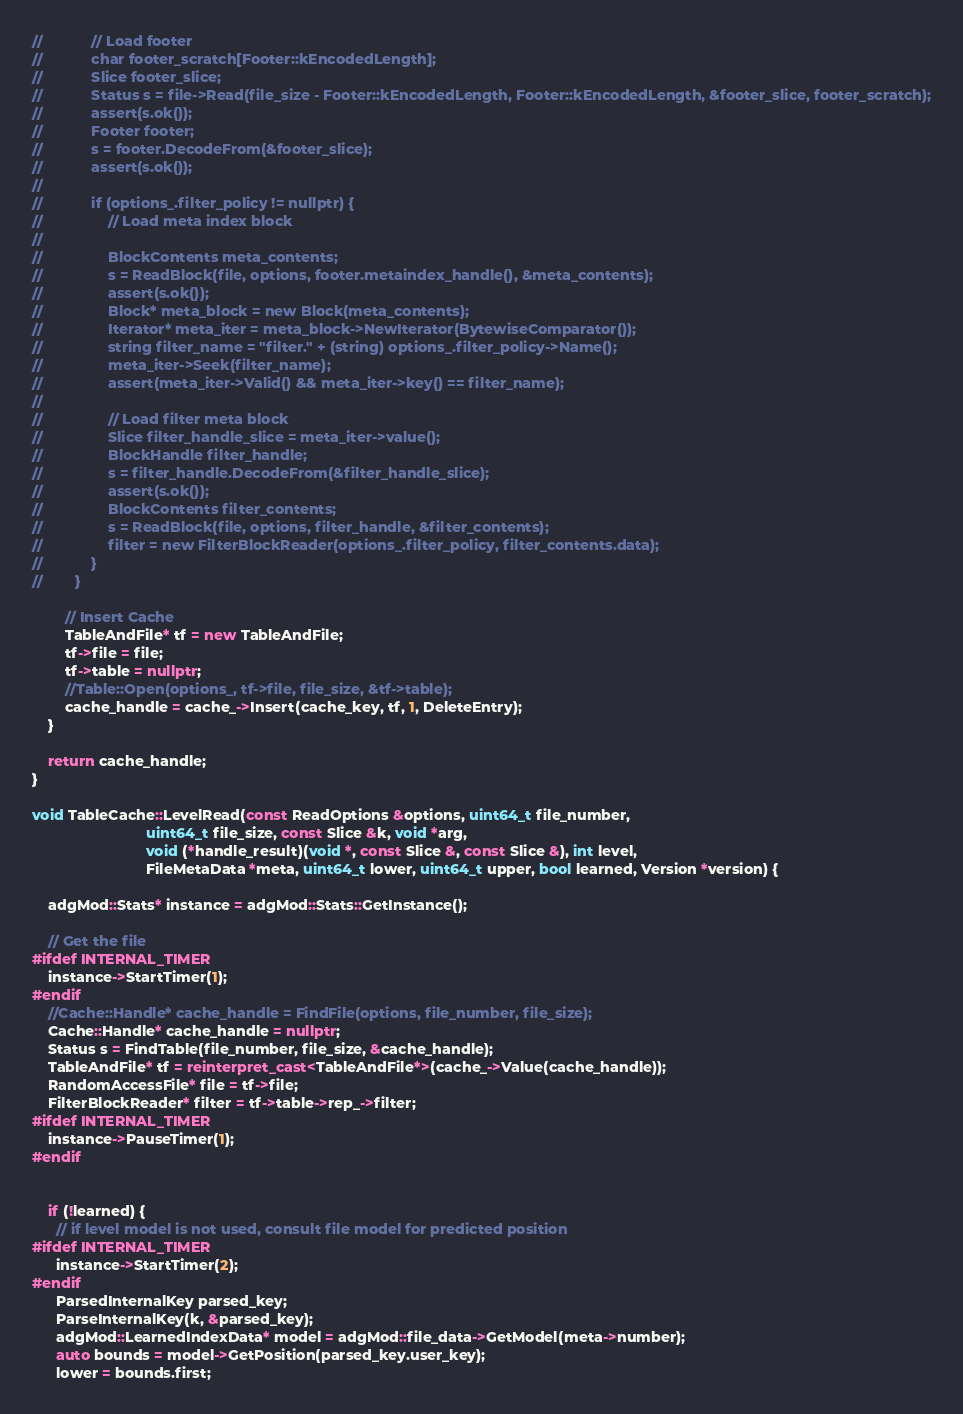<code> <loc_0><loc_0><loc_500><loc_500><_C++_>//            // Load footer
//            char footer_scratch[Footer::kEncodedLength];
//            Slice footer_slice;
//            Status s = file->Read(file_size - Footer::kEncodedLength, Footer::kEncodedLength, &footer_slice, footer_scratch);
//            assert(s.ok());
//            Footer footer;
//            s = footer.DecodeFrom(&footer_slice);
//            assert(s.ok());
//
//            if (options_.filter_policy != nullptr) {
//                // Load meta index block
//
//                BlockContents meta_contents;
//                s = ReadBlock(file, options, footer.metaindex_handle(), &meta_contents);
//                assert(s.ok());
//                Block* meta_block = new Block(meta_contents);
//                Iterator* meta_iter = meta_block->NewIterator(BytewiseComparator());
//                string filter_name = "filter." + (string) options_.filter_policy->Name();
//                meta_iter->Seek(filter_name);
//                assert(meta_iter->Valid() && meta_iter->key() == filter_name);
//
//                // Load filter meta block
//                Slice filter_handle_slice = meta_iter->value();
//                BlockHandle filter_handle;
//                s = filter_handle.DecodeFrom(&filter_handle_slice);
//                assert(s.ok());
//                BlockContents filter_contents;
//                s = ReadBlock(file, options, filter_handle, &filter_contents);
//                filter = new FilterBlockReader(options_.filter_policy, filter_contents.data);
//            }
//        }

        // Insert Cache
        TableAndFile* tf = new TableAndFile;
        tf->file = file;
        tf->table = nullptr;
        //Table::Open(options_, tf->file, file_size, &tf->table);
        cache_handle = cache_->Insert(cache_key, tf, 1, DeleteEntry);
    }

    return cache_handle;
}

void TableCache::LevelRead(const ReadOptions &options, uint64_t file_number,
                            uint64_t file_size, const Slice &k, void *arg,
                            void (*handle_result)(void *, const Slice &, const Slice &), int level,
                            FileMetaData *meta, uint64_t lower, uint64_t upper, bool learned, Version *version) {

    adgMod::Stats* instance = adgMod::Stats::GetInstance();

    // Get the file
#ifdef INTERNAL_TIMER
    instance->StartTimer(1);
#endif
    //Cache::Handle* cache_handle = FindFile(options, file_number, file_size);
    Cache::Handle* cache_handle = nullptr;
    Status s = FindTable(file_number, file_size, &cache_handle);
    TableAndFile* tf = reinterpret_cast<TableAndFile*>(cache_->Value(cache_handle));
    RandomAccessFile* file = tf->file;
    FilterBlockReader* filter = tf->table->rep_->filter;
#ifdef INTERNAL_TIMER
    instance->PauseTimer(1);
#endif


    if (!learned) {
      // if level model is not used, consult file model for predicted position
#ifdef INTERNAL_TIMER
      instance->StartTimer(2);
#endif
      ParsedInternalKey parsed_key;
      ParseInternalKey(k, &parsed_key);
      adgMod::LearnedIndexData* model = adgMod::file_data->GetModel(meta->number);
      auto bounds = model->GetPosition(parsed_key.user_key);
      lower = bounds.first;</code> 